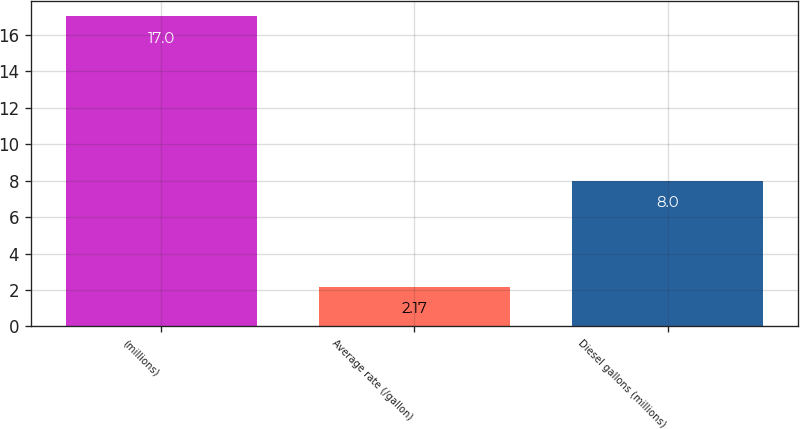Convert chart. <chart><loc_0><loc_0><loc_500><loc_500><bar_chart><fcel>(millions)<fcel>Average rate (/gallon)<fcel>Diesel gallons (millions)<nl><fcel>17<fcel>2.17<fcel>8<nl></chart> 